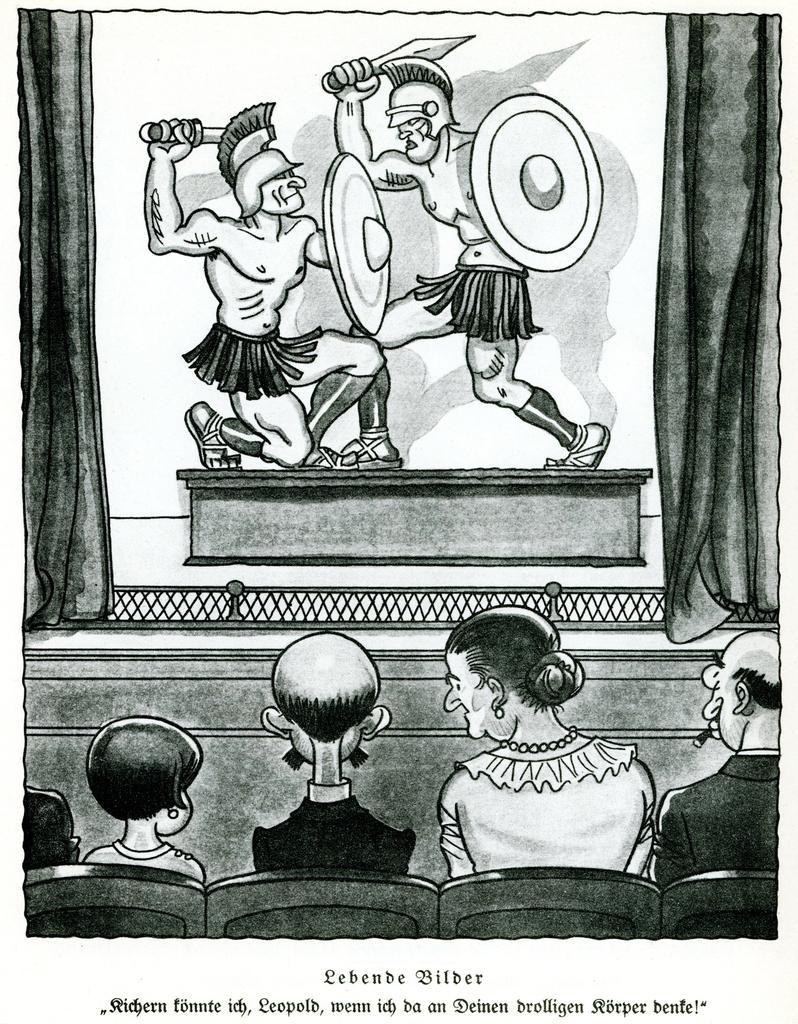How would you summarize this image in a sentence or two? Here we can see a black and white picture, in this picture we can see a sketch of some people sitting on chairs and two persons fighting with swords. 